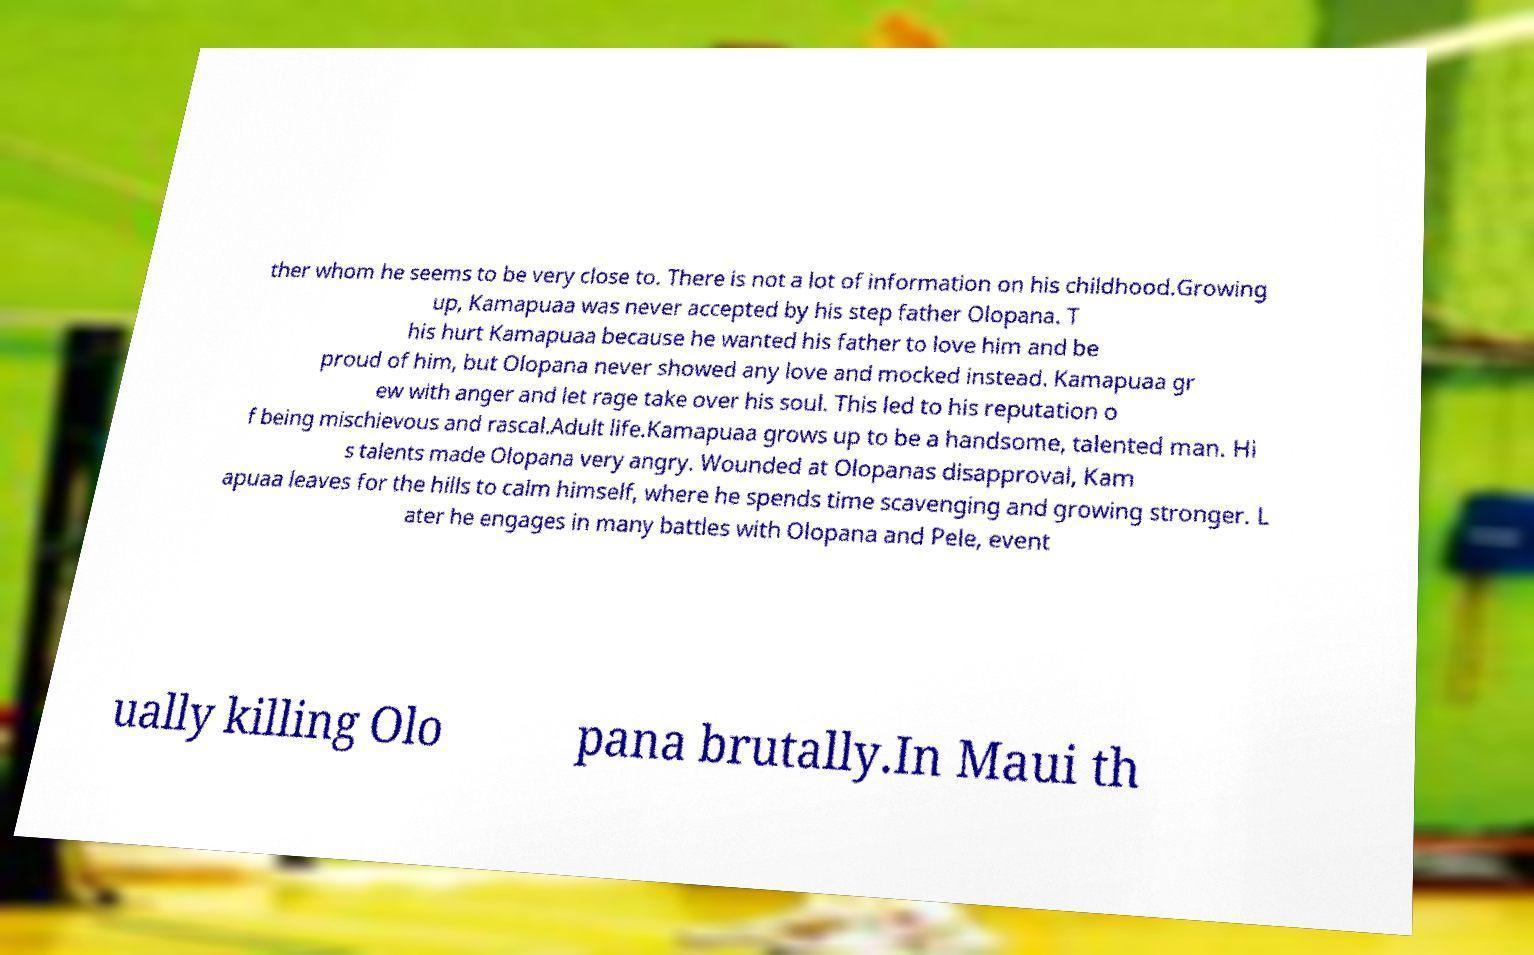What messages or text are displayed in this image? I need them in a readable, typed format. ther whom he seems to be very close to. There is not a lot of information on his childhood.Growing up, Kamapuaa was never accepted by his step father Olopana. T his hurt Kamapuaa because he wanted his father to love him and be proud of him, but Olopana never showed any love and mocked instead. Kamapuaa gr ew with anger and let rage take over his soul. This led to his reputation o f being mischievous and rascal.Adult life.Kamapuaa grows up to be a handsome, talented man. Hi s talents made Olopana very angry. Wounded at Olopanas disapproval, Kam apuaa leaves for the hills to calm himself, where he spends time scavenging and growing stronger. L ater he engages in many battles with Olopana and Pele, event ually killing Olo pana brutally.In Maui th 